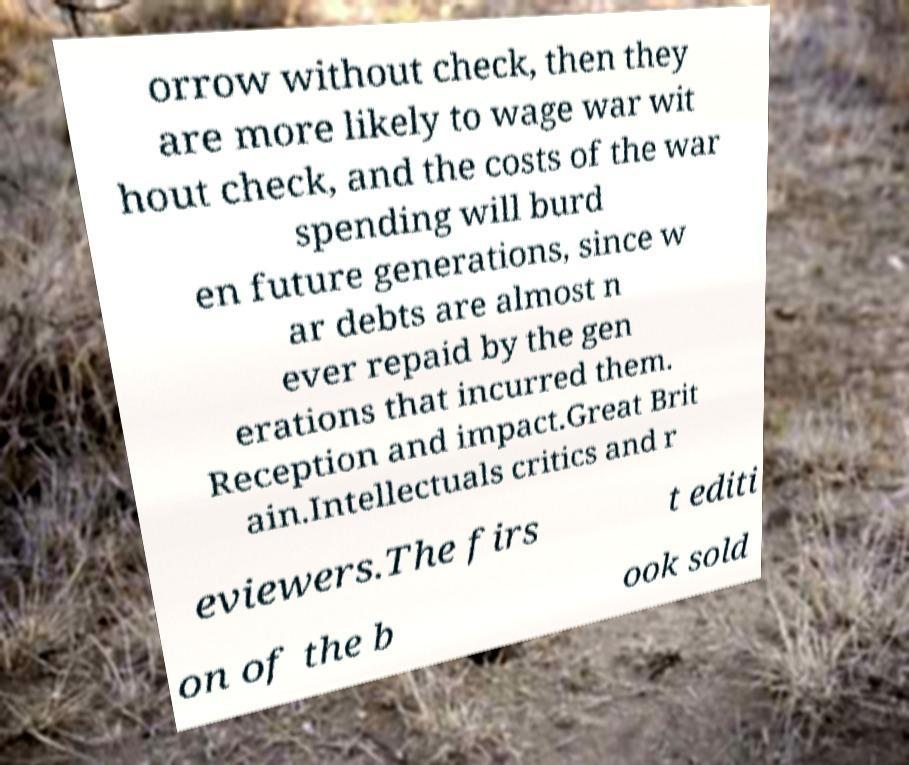I need the written content from this picture converted into text. Can you do that? orrow without check, then they are more likely to wage war wit hout check, and the costs of the war spending will burd en future generations, since w ar debts are almost n ever repaid by the gen erations that incurred them. Reception and impact.Great Brit ain.Intellectuals critics and r eviewers.The firs t editi on of the b ook sold 